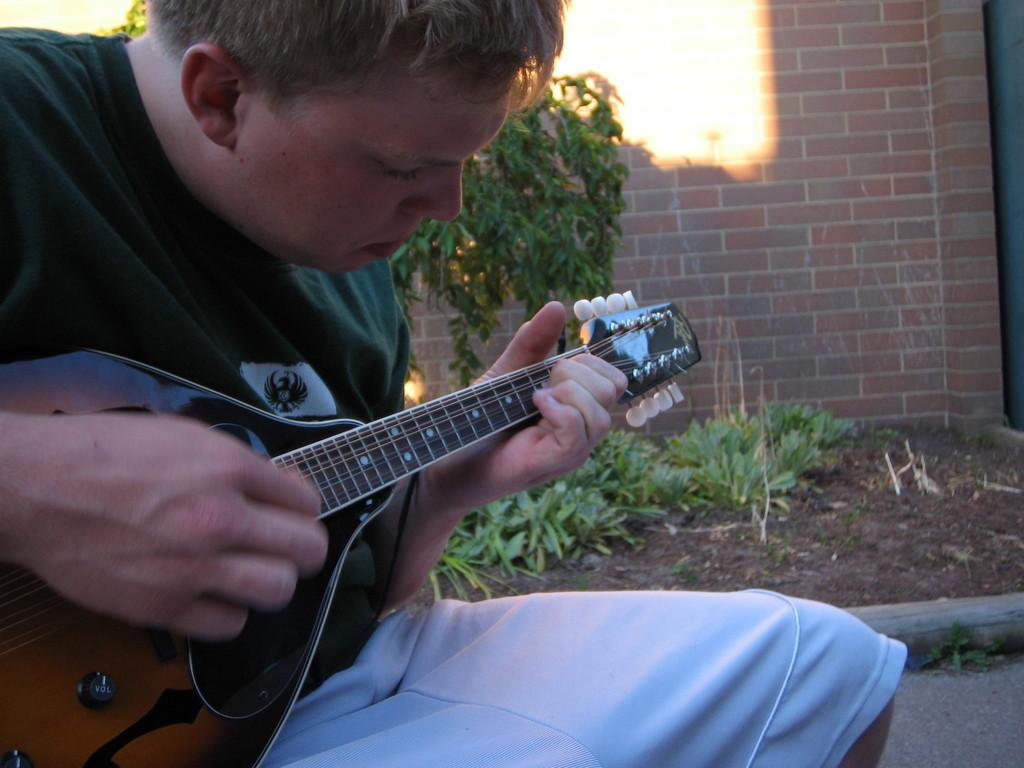What is the main subject of the image? There is a person in the image. What is the person doing in the image? The person is sitting. What object is the person holding in the image? The person is holding a guitar in his hand. What can be seen in the background of the image? There is a wall in the background of the image. What is the wall made of? The wall is made up of red bricks. Can you see a lock on the guitar in the image? There is no lock present on the guitar in the image. Is the person walking down an alley in the image? There is no alley present in the image; it features a person sitting with a guitar and a wall in the background. 